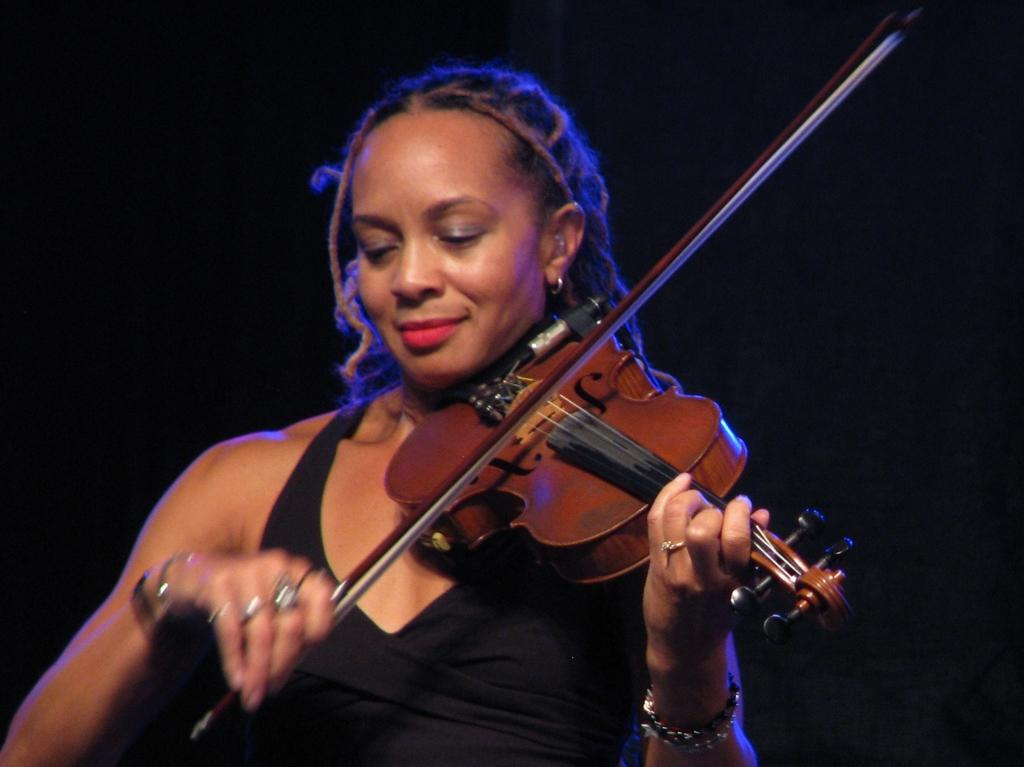What is the main subject of the image? There is a person in the image. What is the person doing in the image? The person is playing the violin. Can you describe the background of the image? The background of the image is dark. How many beads are on the sheet in the image? There is no sheet or beads present in the image. 